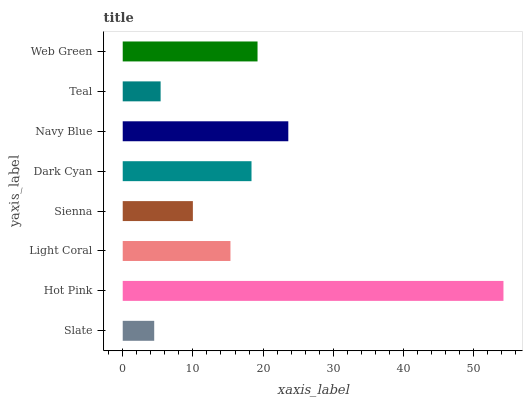Is Slate the minimum?
Answer yes or no. Yes. Is Hot Pink the maximum?
Answer yes or no. Yes. Is Light Coral the minimum?
Answer yes or no. No. Is Light Coral the maximum?
Answer yes or no. No. Is Hot Pink greater than Light Coral?
Answer yes or no. Yes. Is Light Coral less than Hot Pink?
Answer yes or no. Yes. Is Light Coral greater than Hot Pink?
Answer yes or no. No. Is Hot Pink less than Light Coral?
Answer yes or no. No. Is Dark Cyan the high median?
Answer yes or no. Yes. Is Light Coral the low median?
Answer yes or no. Yes. Is Sienna the high median?
Answer yes or no. No. Is Navy Blue the low median?
Answer yes or no. No. 